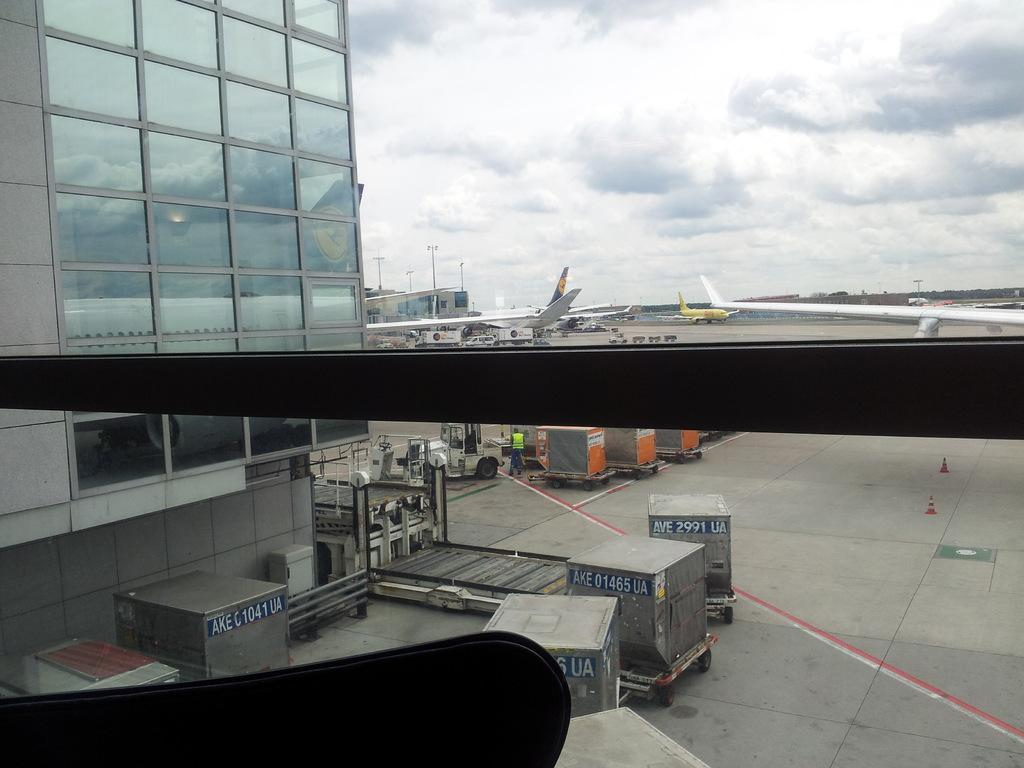What types of transportation are present in the image? There are vehicles in the image. What type of structures can be seen in the image? There are buildings in the image. What other mode of transportation can be seen in the image? There are planes in the image. What safety equipment is present in the image? There are traffic cones in the image. What part of the natural environment is visible in the image? The sky is visible in the image, and there are clouds visible as well. What type of steam is being produced by the carpenter in the image? There is no carpenter or steam present in the image. What type of precipitation can be seen falling from the sky in the image? There is no precipitation visible in the image; only clouds are present. 